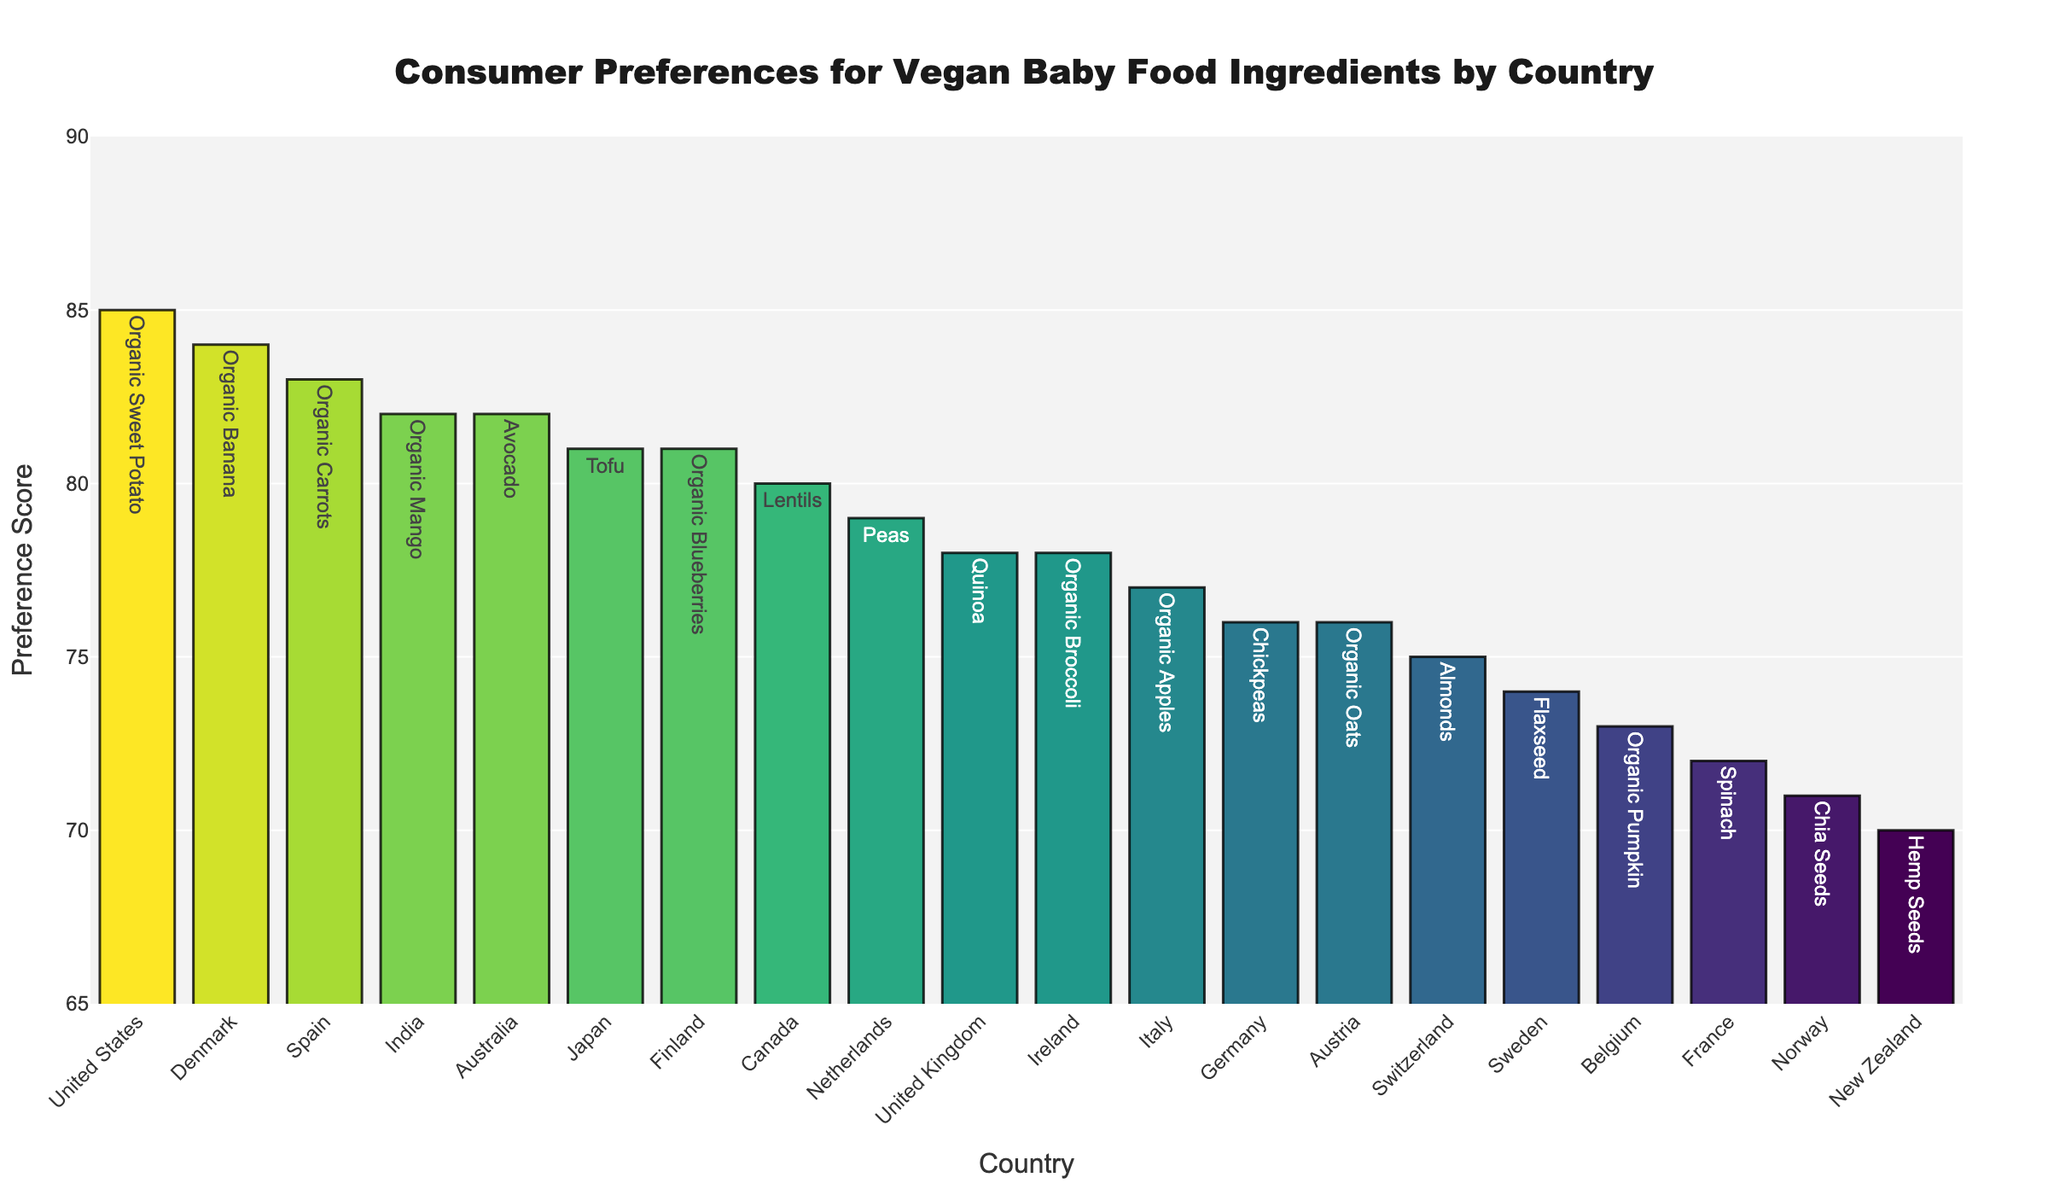What is the most preferred vegan baby food ingredient among the countries listed? The highest bar on the bar chart represents the most preferred ingredient. From the figure, it's clear that the highest preference score is for Organic Sweet Potato from the United States, at a score of 85.
Answer: Organic Sweet Potato Which country has the least preference score for its vegan baby food ingredient, and what is the ingredient? The smallest bar on the bar chart indicates the lowest preference score. The bar with the lowest score is for New Zealand, with Hemp Seeds, at a preference score of 70.
Answer: New Zealand, Hemp Seeds Comparing organic ingredients, which two countries have the highest preference scores, and what are the ingredients? Look for bars with the highest scores labeled with organic ingredients. The top two scores for organic ingredients are from the United States (Organic Sweet Potato, 85) and Denmark (Organic Banana, 84).
Answer: United States (Organic Sweet Potato), Denmark (Organic Banana) How does the preference score for Avocado in Australia compare to the preference score for Tofu in Japan? Identify the bars representing Australia and Japan. Compare the height and score values of Avocado (Australia, 82) to Tofu (Japan, 81).
Answer: 82 (Avocado) is higher than 81 (Tofu) Calculate the average preference score for the European countries listed (United Kingdom, Germany, France, Netherlands, Sweden, Spain, Italy, Norway, Denmark, Switzerland, Belgium, Ireland, Finland, Austria). Sum the preference scores for the European countries and divide by the number of countries. The sum of the scores is 78+76+72+79+74+83+77+71+84+75+73+78+81+76 = 997; there are 14 countries, so the average is 997/14 ≈ 71.21.
Answer: ~71.21 What is the combined preference score for organic ingredients across all countries? Identify the scores labeled with 'Organic' and sum them: 85 (Sweet Potato) + 83 (Carrots) + 84 (Banana) + 77 (Apples) + 78 (Broccoli) + 81 (Blueberries) + 76 (Oats) + 82 (Mango) = 646.
Answer: 646 